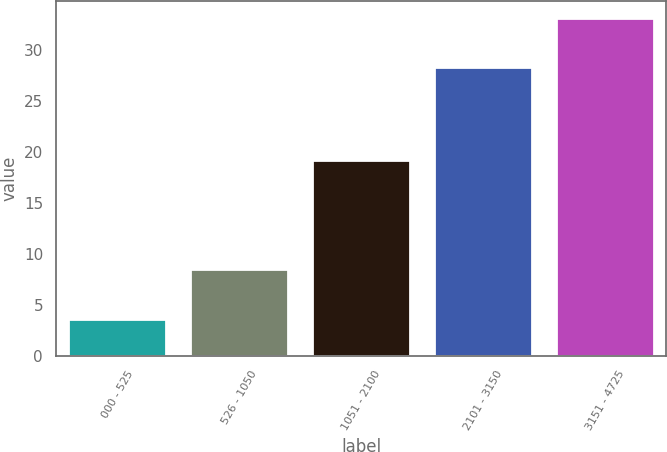Convert chart to OTSL. <chart><loc_0><loc_0><loc_500><loc_500><bar_chart><fcel>000 - 525<fcel>526 - 1050<fcel>1051 - 2100<fcel>2101 - 3150<fcel>3151 - 4725<nl><fcel>3.61<fcel>8.54<fcel>19.25<fcel>28.32<fcel>33.2<nl></chart> 